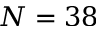Convert formula to latex. <formula><loc_0><loc_0><loc_500><loc_500>N = 3 8</formula> 